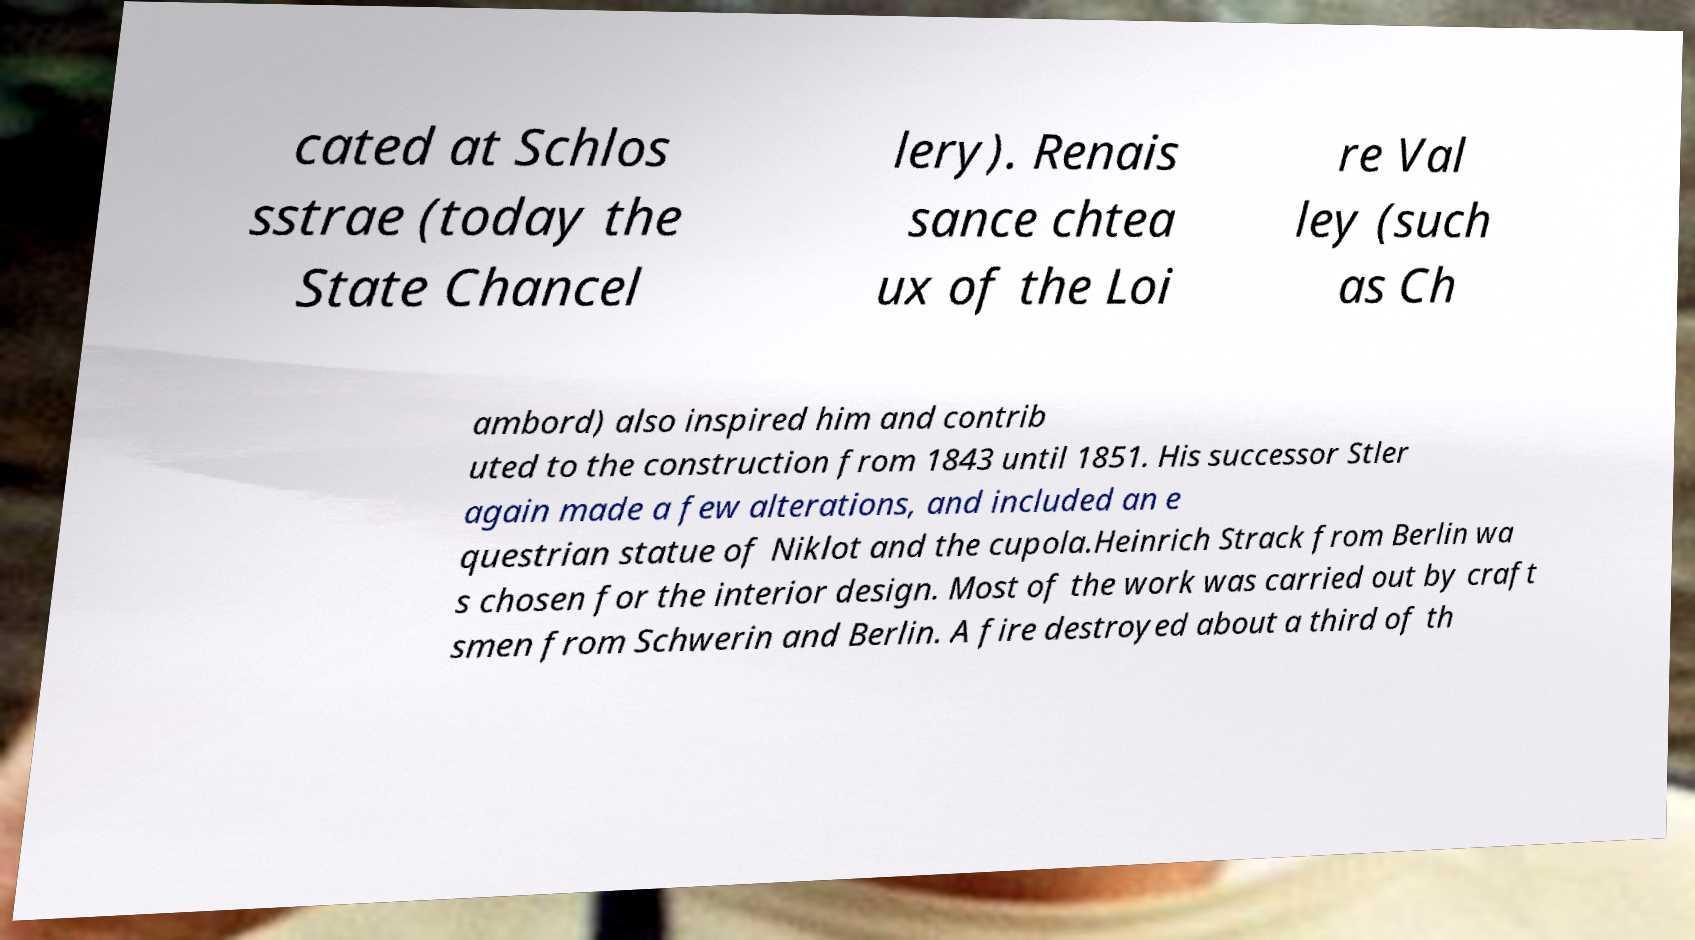Please read and relay the text visible in this image. What does it say? cated at Schlos sstrae (today the State Chancel lery). Renais sance chtea ux of the Loi re Val ley (such as Ch ambord) also inspired him and contrib uted to the construction from 1843 until 1851. His successor Stler again made a few alterations, and included an e questrian statue of Niklot and the cupola.Heinrich Strack from Berlin wa s chosen for the interior design. Most of the work was carried out by craft smen from Schwerin and Berlin. A fire destroyed about a third of th 